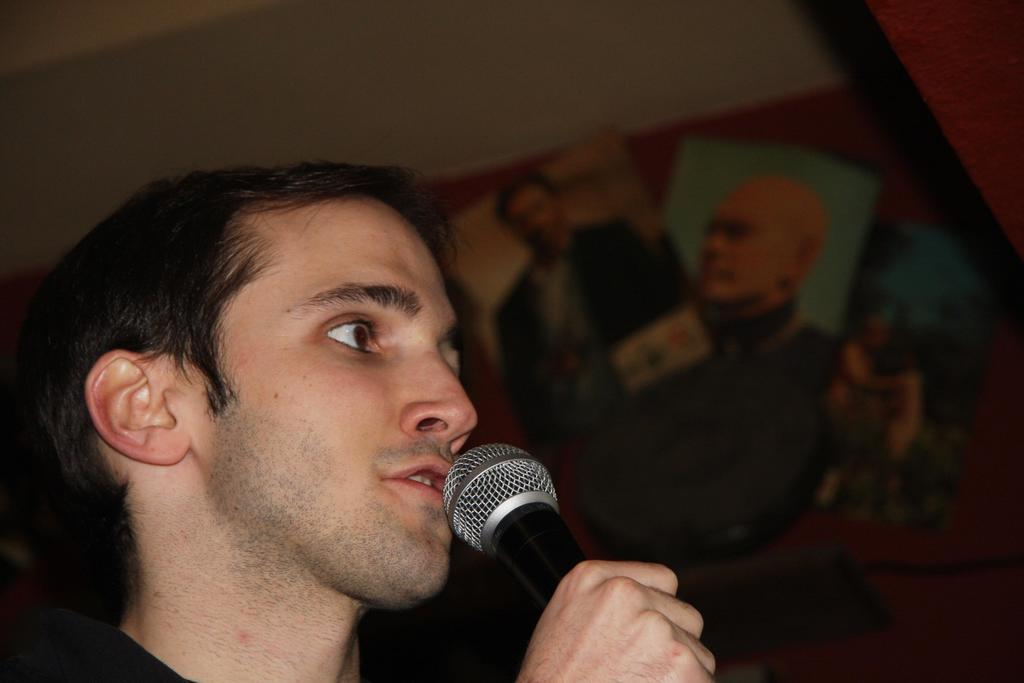Who or what is the main subject of the image? There is a person in the image. What is the person holding in the image? The person is holding a microphone. What type of ornament is hanging from the table in the image? There is no table or ornament present in the image. Who is the owner of the microphone in the image? The image does not provide information about the ownership of the microphone. 